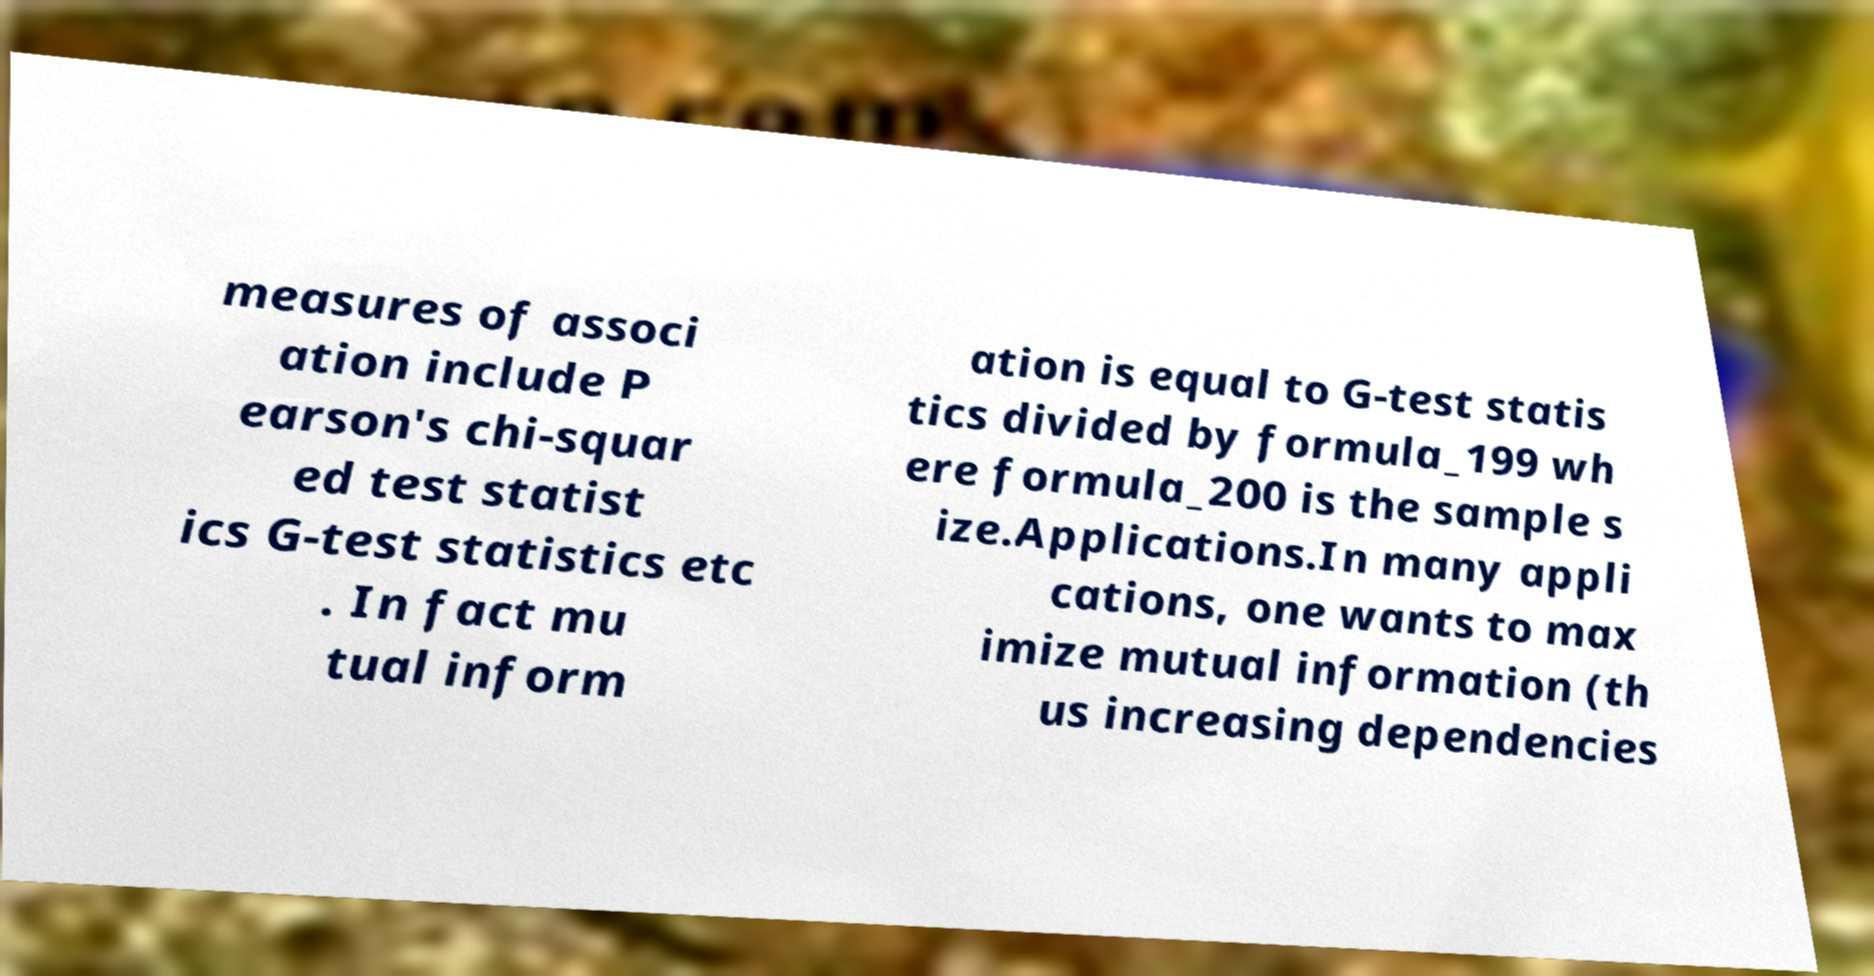I need the written content from this picture converted into text. Can you do that? measures of associ ation include P earson's chi-squar ed test statist ics G-test statistics etc . In fact mu tual inform ation is equal to G-test statis tics divided by formula_199 wh ere formula_200 is the sample s ize.Applications.In many appli cations, one wants to max imize mutual information (th us increasing dependencies 